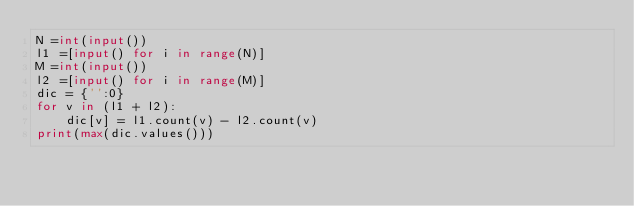Convert code to text. <code><loc_0><loc_0><loc_500><loc_500><_Python_>N =int(input())
l1 =[input() for i in range(N)]
M =int(input())
l2 =[input() for i in range(M)]
dic = {'':0}
for v in (l1 + l2):
    dic[v] = l1.count(v) - l2.count(v)
print(max(dic.values()))</code> 